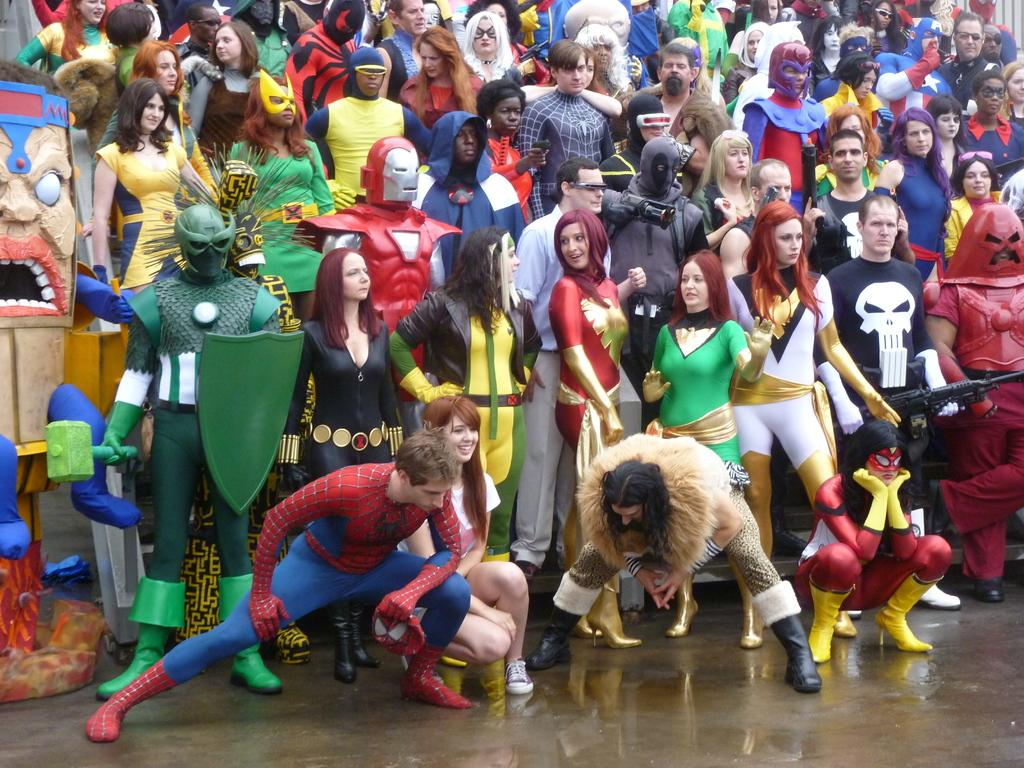How many people are present in the image? There are many people in the image. What are some people wearing in the image? Some people are wearing costumes in the image. What are some people holding in their hands in the image? Some people are holding objects in their hands in the image. Can you describe the object on the left side of the image? Unfortunately, there is no specific information about the object on the left side of the image. What type of glove is being worn by the person in the image? There is no mention of gloves being worn by anyone in the image. 